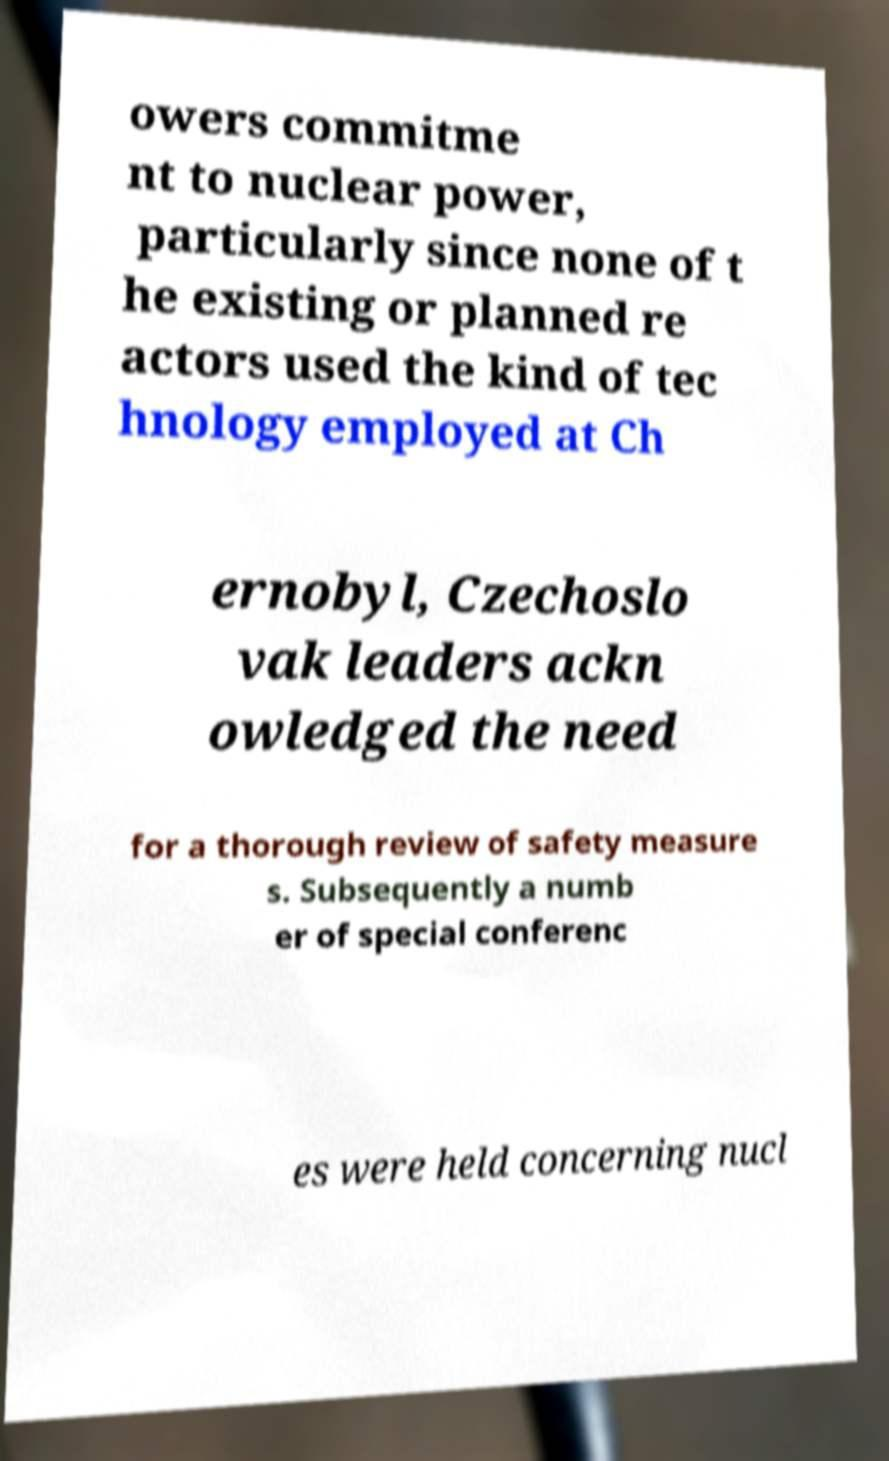Could you extract and type out the text from this image? owers commitme nt to nuclear power, particularly since none of t he existing or planned re actors used the kind of tec hnology employed at Ch ernobyl, Czechoslo vak leaders ackn owledged the need for a thorough review of safety measure s. Subsequently a numb er of special conferenc es were held concerning nucl 